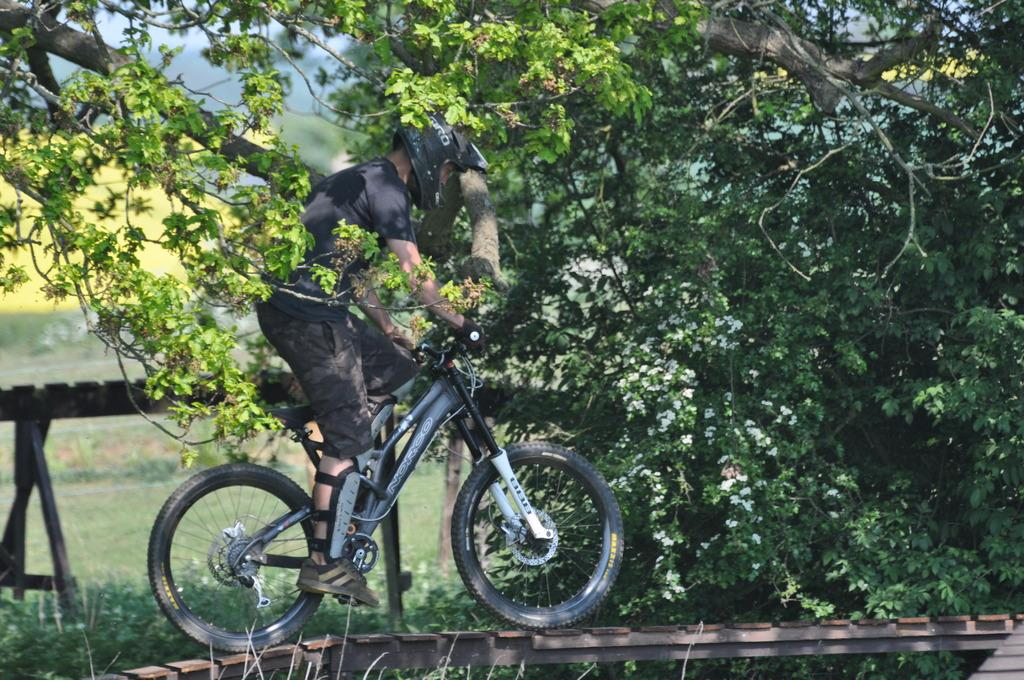What is the man in the image doing? The man is riding a bicycle in the image. What is the surface the bicycle is on? The bicycle is on a wooden walkway. What is the man wearing? The man is wearing a black T-shirt and black trousers. What can be seen in the background of the image? There are trees in the background of the image. What type of coat is the man wearing in the image? The man is not wearing a coat in the image; he is wearing a black T-shirt. Is there any sleet visible in the image? There is no mention of sleet in the provided facts, and it is not visible in the image. 